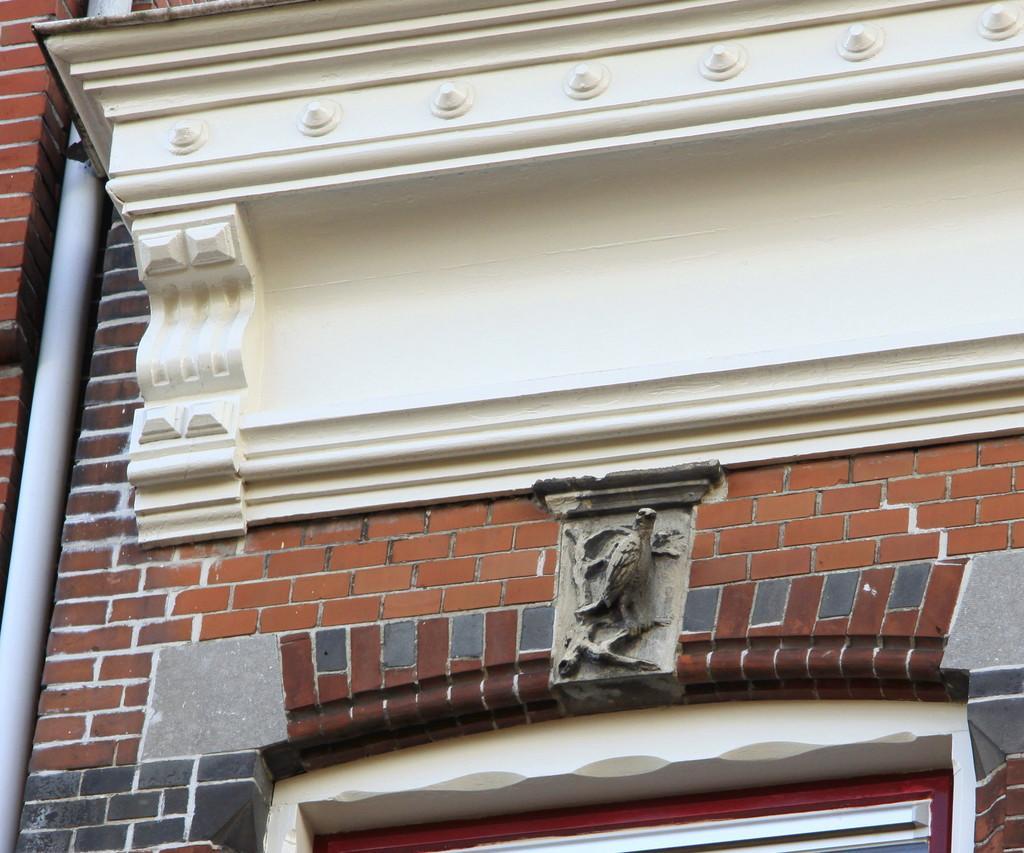In one or two sentences, can you explain what this image depicts? In this image there is a wall to that wall there is a cornice, below that there is a sculpture, below the sculpture there is a window, on the left there is a pipe. 